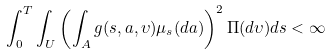Convert formula to latex. <formula><loc_0><loc_0><loc_500><loc_500>\int _ { 0 } ^ { T } \int _ { U } \left ( \int _ { A } g ( s , a , \upsilon ) \mu _ { s } ( d a ) \right ) ^ { 2 } \Pi ( d \upsilon ) d s < \infty</formula> 